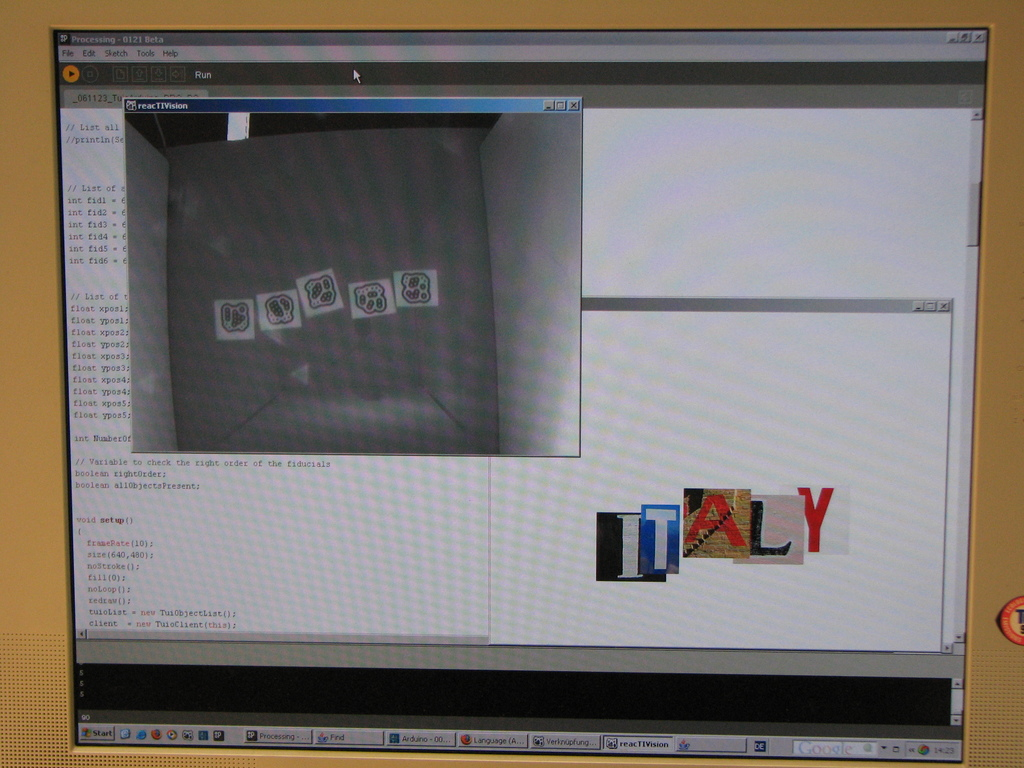What software is being used in this image and what is its primary purpose? The software shown in the image is 'reacTIVision', which is primarily used for tracking fiducial markers in real-time interactive systems, aiding in multimedia projects and interactive applications. How does the layout of this software interface contribute to its functionality? The interface is designed for clarity and accessibility; the large viewing area for the grid with fiducial markers allows users to monitor changes in real-time, while the separate window for project elements, like the ITALY images, helps in organizing content efficiently. 